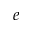<formula> <loc_0><loc_0><loc_500><loc_500>e</formula> 